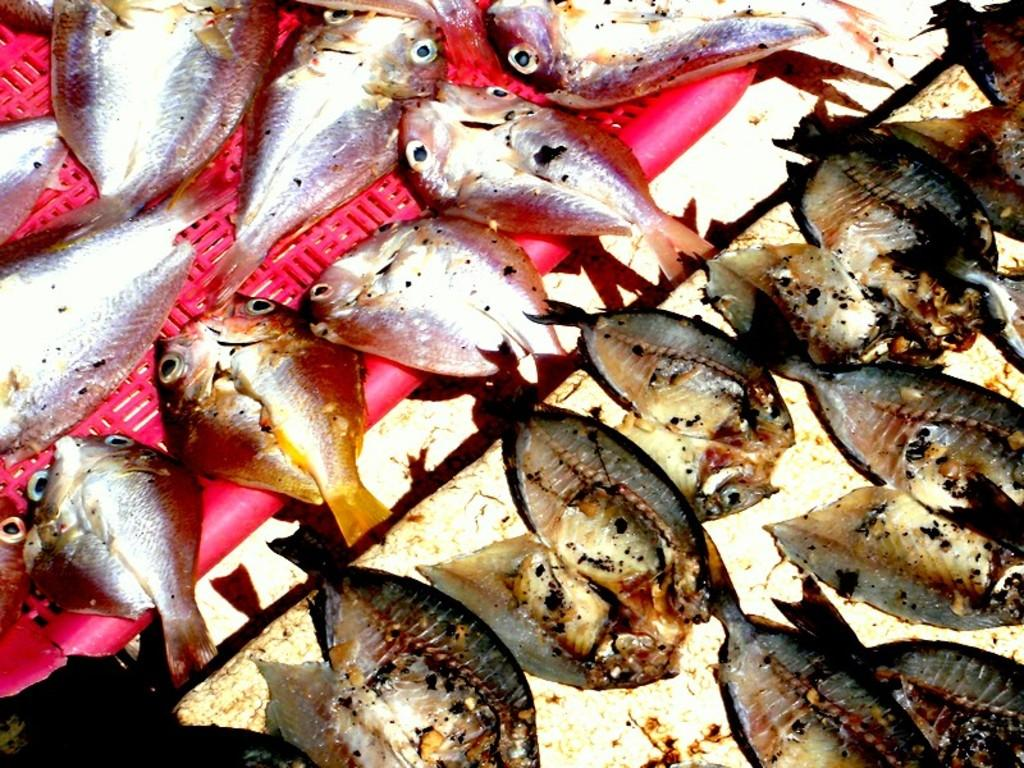What type of animals are on the table in the image? There are fishes on the table in the image. Can you describe the setting where the fishes are located? The fishes are on a table, which suggests they might be part of a meal or display. What team is playing on the coast in the image? There is no team or coast present in the image; it features fishes on a table. 